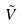<formula> <loc_0><loc_0><loc_500><loc_500>\tilde { V }</formula> 